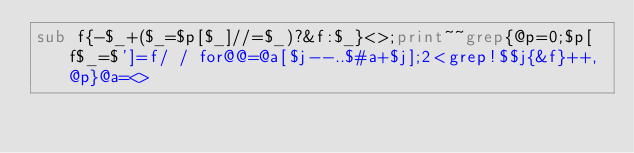<code> <loc_0><loc_0><loc_500><loc_500><_Perl_>sub f{-$_+($_=$p[$_]//=$_)?&f:$_}<>;print~~grep{@p=0;$p[f$_=$']=f/ / for@@=@a[$j--..$#a+$j];2<grep!$$j{&f}++,@p}@a=<></code> 